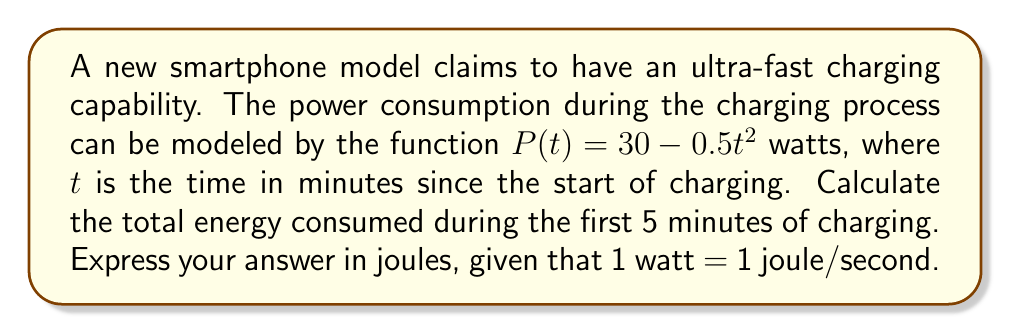Could you help me with this problem? To solve this problem, we need to find the area under the curve of the power consumption function over the given time interval. This can be done using a definite integral.

1) The power consumption function is given as:
   $P(t) = 30 - 0.5t^2$ watts

2) To find the total energy consumed, we need to integrate this function over the time interval [0, 5] minutes:
   $$E = \int_0^5 P(t) dt = \int_0^5 (30 - 0.5t^2) dt$$

3) Let's solve this integral:
   $$E = [30t - \frac{1}{6}t^3]_0^5$$

4) Evaluate the antiderivative at the limits:
   $$E = (30 \cdot 5 - \frac{1}{6} \cdot 5^3) - (30 \cdot 0 - \frac{1}{6} \cdot 0^3)$$
   $$E = (150 - \frac{125}{6}) - 0$$
   $$E = 150 - 20.8333...$$
   $$E = 129.1666...$$

5) This result is in watt-minutes. To convert to joules:
   - First, convert minutes to seconds: 129.1666... * 60 = 7750 watt-seconds
   - Since 1 watt-second = 1 joule, the final answer is 7750 joules
Answer: The total energy consumed during the first 5 minutes of charging is approximately 7750 joules. 